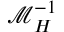Convert formula to latex. <formula><loc_0><loc_0><loc_500><loc_500>\mathcal { M } _ { H } ^ { - 1 }</formula> 